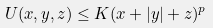Convert formula to latex. <formula><loc_0><loc_0><loc_500><loc_500>U ( x , y , z ) \leq K ( x + | y | + z ) ^ { p }</formula> 